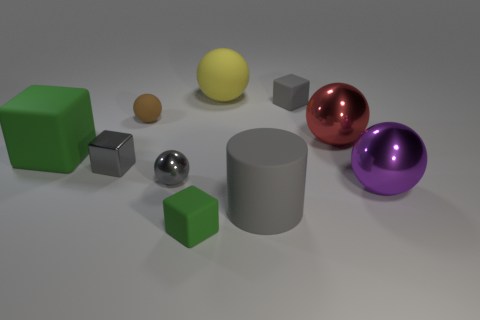Subtract 1 blocks. How many blocks are left? 3 Subtract all red balls. How many balls are left? 4 Subtract all cyan spheres. Subtract all green cylinders. How many spheres are left? 5 Subtract all cylinders. How many objects are left? 9 Subtract 0 brown cubes. How many objects are left? 10 Subtract all big matte blocks. Subtract all large matte blocks. How many objects are left? 8 Add 7 gray metal objects. How many gray metal objects are left? 9 Add 3 small green rubber cylinders. How many small green rubber cylinders exist? 3 